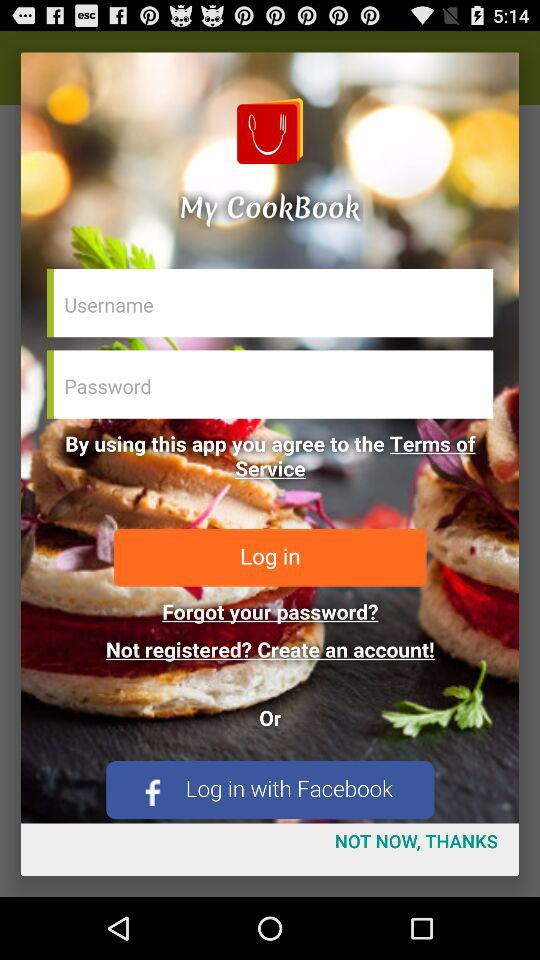Through what applications can we log in? You can log in through "Facebook". 